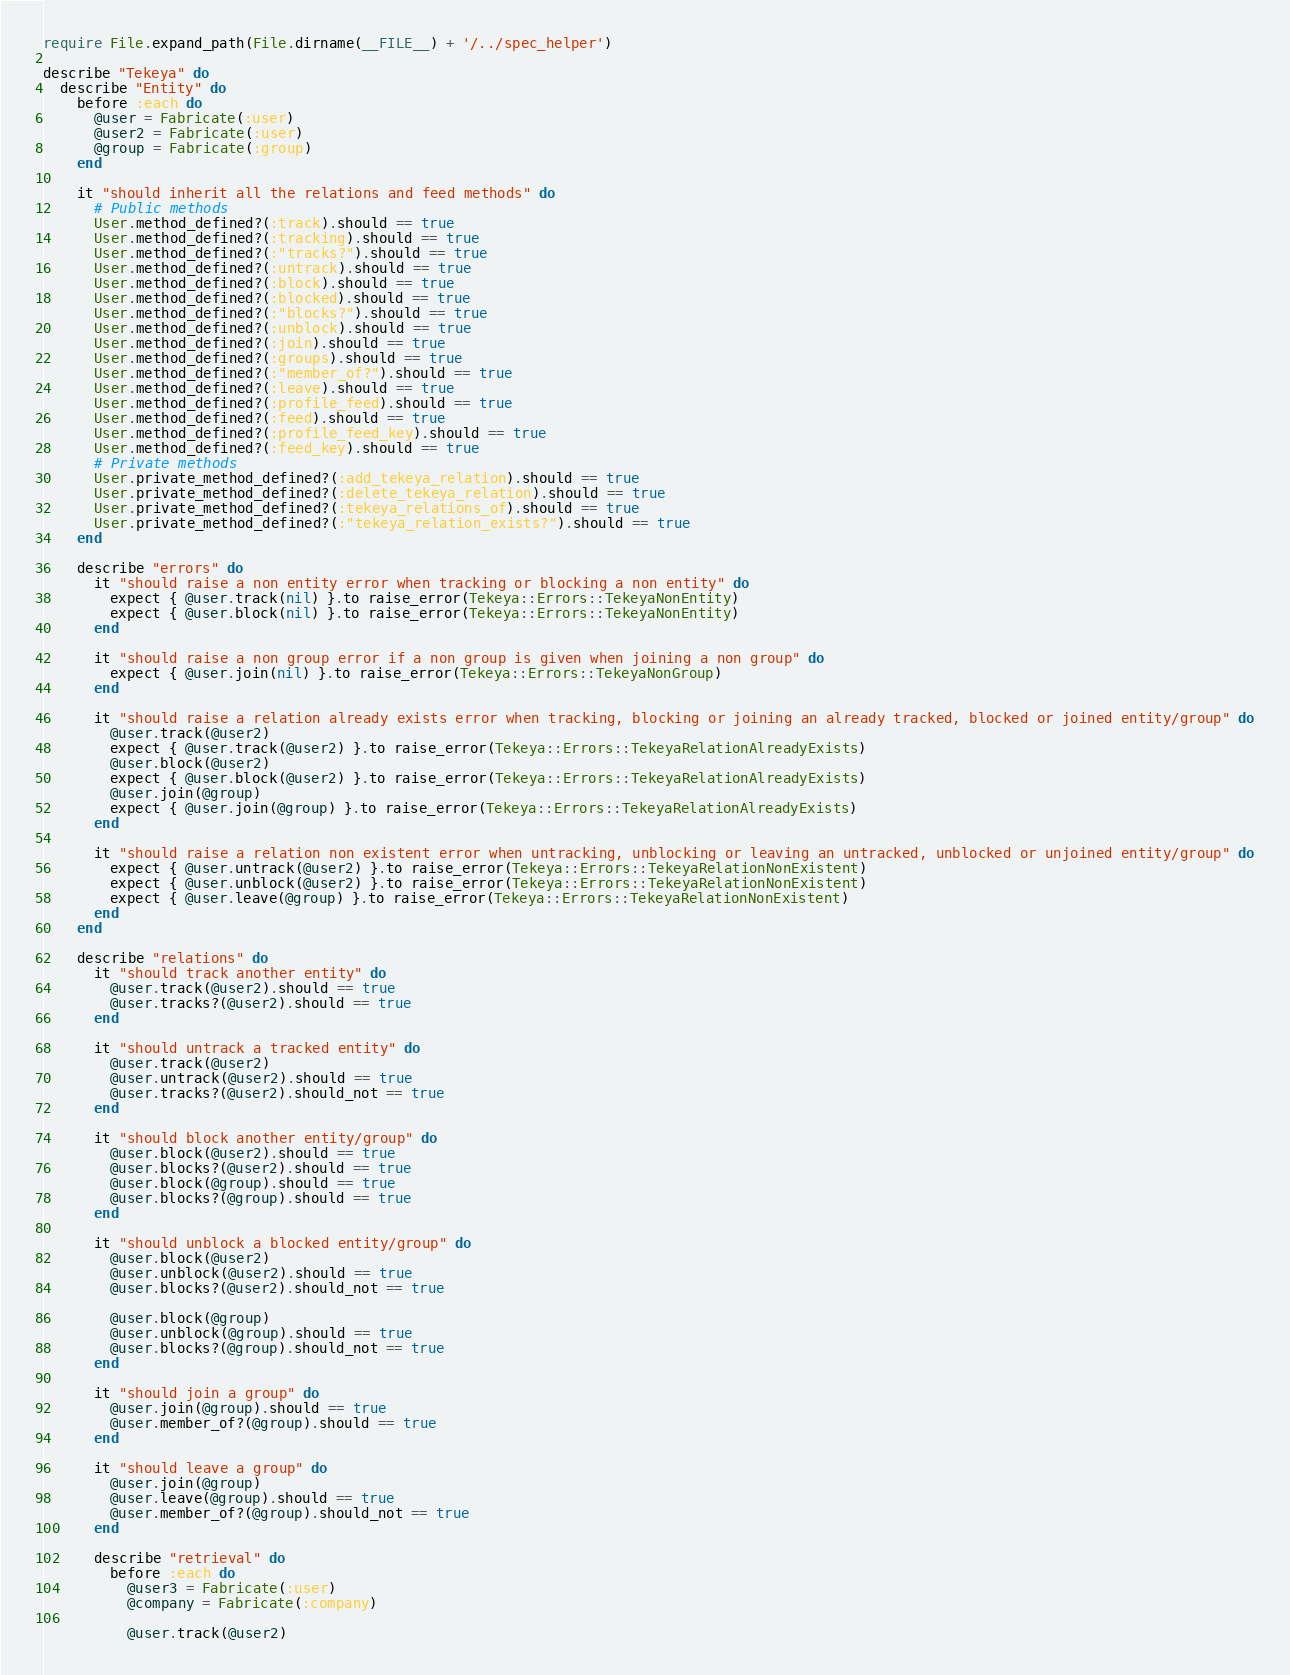Convert code to text. <code><loc_0><loc_0><loc_500><loc_500><_Ruby_>require File.expand_path(File.dirname(__FILE__) + '/../spec_helper')

describe "Tekeya" do
  describe "Entity" do
    before :each do
      @user = Fabricate(:user)
      @user2 = Fabricate(:user)
      @group = Fabricate(:group)
    end

    it "should inherit all the relations and feed methods" do
      # Public methods
      User.method_defined?(:track).should == true
      User.method_defined?(:tracking).should == true
      User.method_defined?(:"tracks?").should == true
      User.method_defined?(:untrack).should == true
      User.method_defined?(:block).should == true
      User.method_defined?(:blocked).should == true
      User.method_defined?(:"blocks?").should == true
      User.method_defined?(:unblock).should == true
      User.method_defined?(:join).should == true
      User.method_defined?(:groups).should == true
      User.method_defined?(:"member_of?").should == true
      User.method_defined?(:leave).should == true
      User.method_defined?(:profile_feed).should == true
      User.method_defined?(:feed).should == true
      User.method_defined?(:profile_feed_key).should == true
      User.method_defined?(:feed_key).should == true
      # Private methods
      User.private_method_defined?(:add_tekeya_relation).should == true
      User.private_method_defined?(:delete_tekeya_relation).should == true
      User.private_method_defined?(:tekeya_relations_of).should == true
      User.private_method_defined?(:"tekeya_relation_exists?").should == true
    end

    describe "errors" do
      it "should raise a non entity error when tracking or blocking a non entity" do
        expect { @user.track(nil) }.to raise_error(Tekeya::Errors::TekeyaNonEntity)
        expect { @user.block(nil) }.to raise_error(Tekeya::Errors::TekeyaNonEntity)
      end

      it "should raise a non group error if a non group is given when joining a non group" do
        expect { @user.join(nil) }.to raise_error(Tekeya::Errors::TekeyaNonGroup)
      end

      it "should raise a relation already exists error when tracking, blocking or joining an already tracked, blocked or joined entity/group" do
        @user.track(@user2)
        expect { @user.track(@user2) }.to raise_error(Tekeya::Errors::TekeyaRelationAlreadyExists)
        @user.block(@user2)
        expect { @user.block(@user2) }.to raise_error(Tekeya::Errors::TekeyaRelationAlreadyExists)
        @user.join(@group)
        expect { @user.join(@group) }.to raise_error(Tekeya::Errors::TekeyaRelationAlreadyExists)
      end

      it "should raise a relation non existent error when untracking, unblocking or leaving an untracked, unblocked or unjoined entity/group" do
        expect { @user.untrack(@user2) }.to raise_error(Tekeya::Errors::TekeyaRelationNonExistent)
        expect { @user.unblock(@user2) }.to raise_error(Tekeya::Errors::TekeyaRelationNonExistent)
        expect { @user.leave(@group) }.to raise_error(Tekeya::Errors::TekeyaRelationNonExistent)
      end
    end

    describe "relations" do
      it "should track another entity" do
        @user.track(@user2).should == true
        @user.tracks?(@user2).should == true
      end

      it "should untrack a tracked entity" do
        @user.track(@user2)
        @user.untrack(@user2).should == true
        @user.tracks?(@user2).should_not == true
      end

      it "should block another entity/group" do
        @user.block(@user2).should == true
        @user.blocks?(@user2).should == true
        @user.block(@group).should == true
        @user.blocks?(@group).should == true
      end

      it "should unblock a blocked entity/group" do
        @user.block(@user2)
        @user.unblock(@user2).should == true
        @user.blocks?(@user2).should_not == true

        @user.block(@group)
        @user.unblock(@group).should == true
        @user.blocks?(@group).should_not == true
      end

      it "should join a group" do
        @user.join(@group).should == true
        @user.member_of?(@group).should == true
      end

      it "should leave a group" do
        @user.join(@group)
        @user.leave(@group).should == true
        @user.member_of?(@group).should_not == true
      end

      describe "retrieval" do
        before :each do
          @user3 = Fabricate(:user)
          @company = Fabricate(:company)

          @user.track(@user2)</code> 